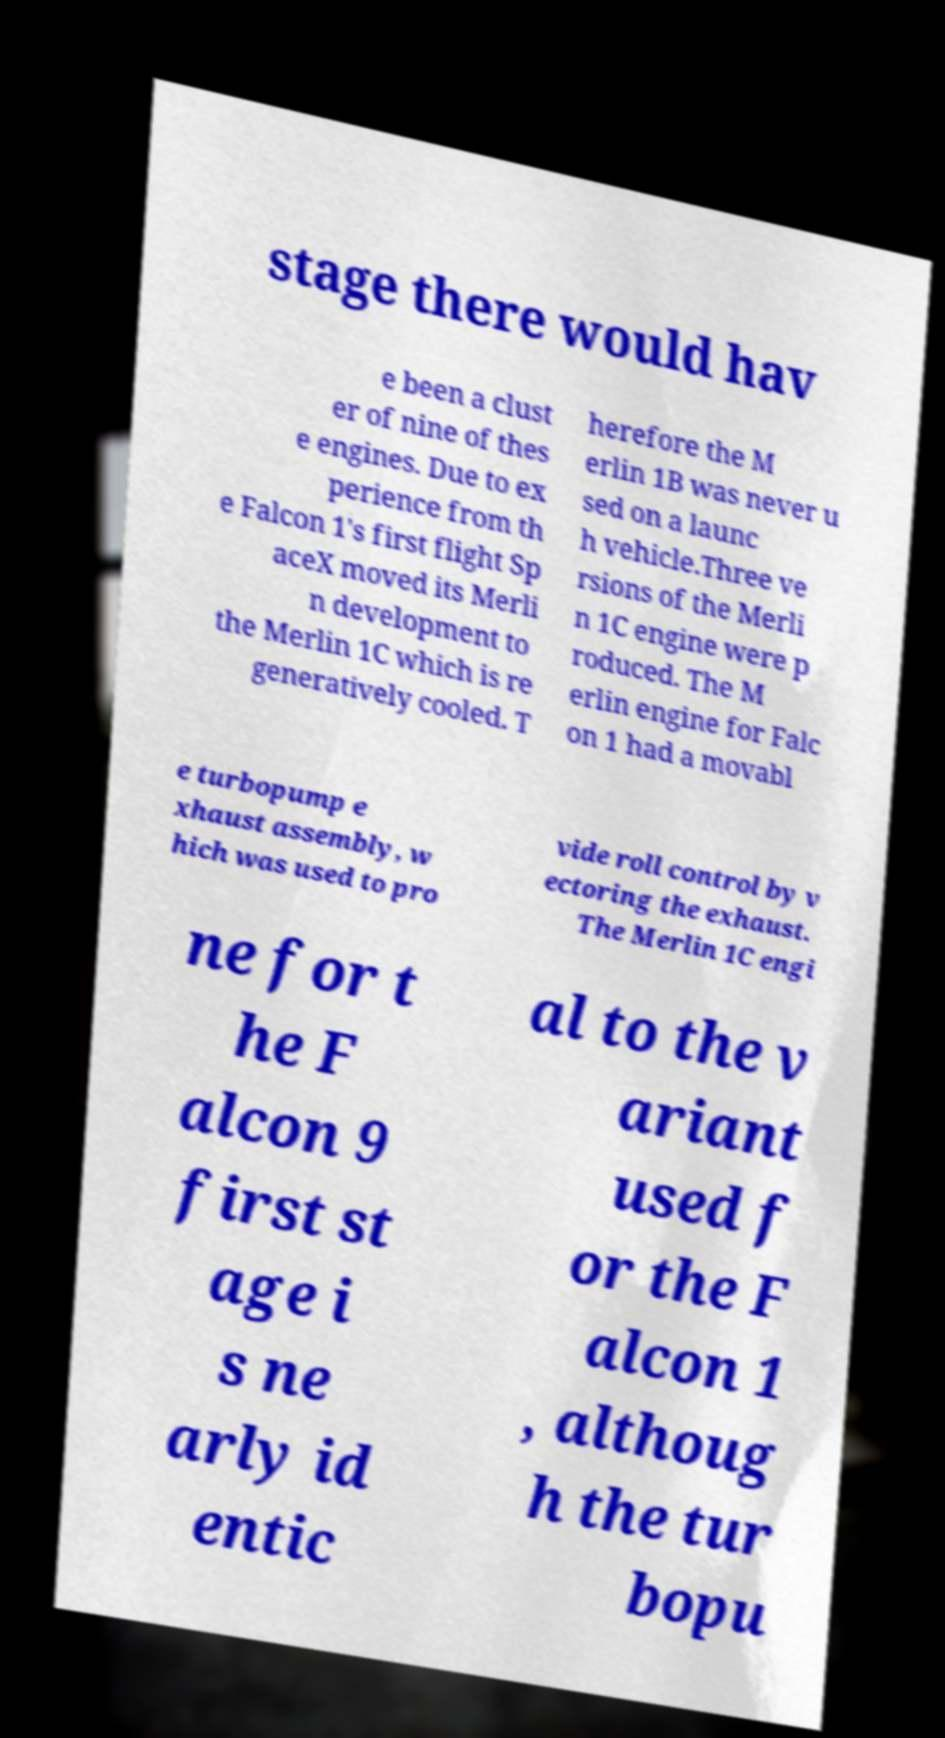Could you extract and type out the text from this image? stage there would hav e been a clust er of nine of thes e engines. Due to ex perience from th e Falcon 1's first flight Sp aceX moved its Merli n development to the Merlin 1C which is re generatively cooled. T herefore the M erlin 1B was never u sed on a launc h vehicle.Three ve rsions of the Merli n 1C engine were p roduced. The M erlin engine for Falc on 1 had a movabl e turbopump e xhaust assembly, w hich was used to pro vide roll control by v ectoring the exhaust. The Merlin 1C engi ne for t he F alcon 9 first st age i s ne arly id entic al to the v ariant used f or the F alcon 1 , althoug h the tur bopu 